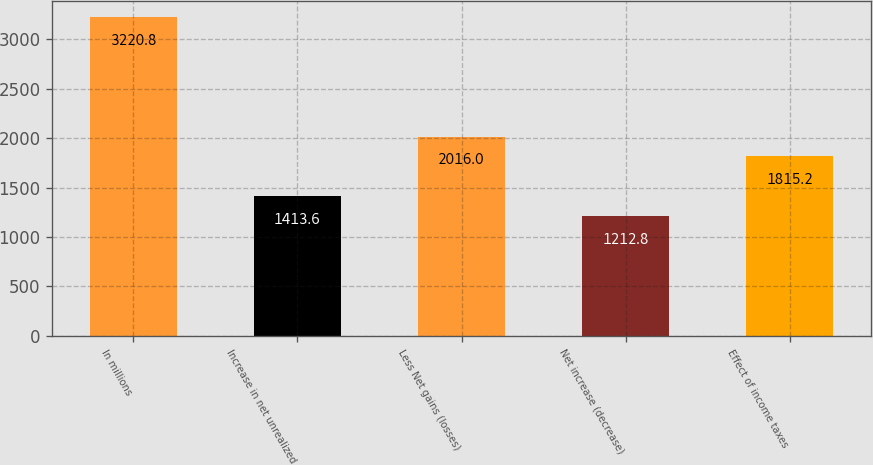<chart> <loc_0><loc_0><loc_500><loc_500><bar_chart><fcel>In millions<fcel>Increase in net unrealized<fcel>Less Net gains (losses)<fcel>Net increase (decrease)<fcel>Effect of income taxes<nl><fcel>3220.8<fcel>1413.6<fcel>2016<fcel>1212.8<fcel>1815.2<nl></chart> 